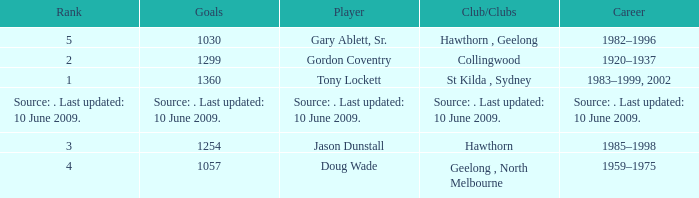In what club(s) does Tony Lockett play? St Kilda , Sydney. 